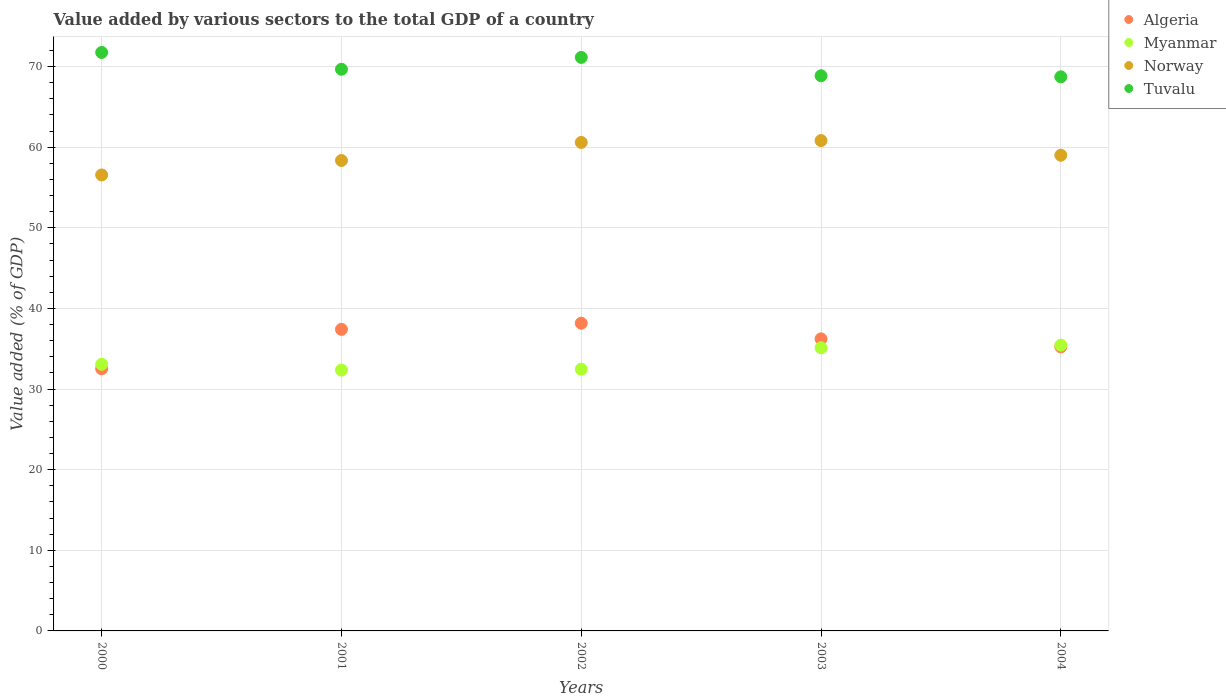How many different coloured dotlines are there?
Offer a very short reply. 4. Is the number of dotlines equal to the number of legend labels?
Your answer should be compact. Yes. What is the value added by various sectors to the total GDP in Norway in 2003?
Your answer should be very brief. 60.82. Across all years, what is the maximum value added by various sectors to the total GDP in Algeria?
Ensure brevity in your answer.  38.17. Across all years, what is the minimum value added by various sectors to the total GDP in Norway?
Your answer should be very brief. 56.56. In which year was the value added by various sectors to the total GDP in Myanmar maximum?
Your answer should be compact. 2004. In which year was the value added by various sectors to the total GDP in Algeria minimum?
Provide a succinct answer. 2000. What is the total value added by various sectors to the total GDP in Algeria in the graph?
Provide a short and direct response. 179.54. What is the difference between the value added by various sectors to the total GDP in Myanmar in 2000 and that in 2002?
Make the answer very short. 0.6. What is the difference between the value added by various sectors to the total GDP in Algeria in 2004 and the value added by various sectors to the total GDP in Norway in 2000?
Keep it short and to the point. -21.32. What is the average value added by various sectors to the total GDP in Myanmar per year?
Your answer should be very brief. 33.69. In the year 2002, what is the difference between the value added by various sectors to the total GDP in Norway and value added by various sectors to the total GDP in Myanmar?
Ensure brevity in your answer.  28.12. What is the ratio of the value added by various sectors to the total GDP in Tuvalu in 2000 to that in 2002?
Offer a terse response. 1.01. Is the value added by various sectors to the total GDP in Myanmar in 2003 less than that in 2004?
Ensure brevity in your answer.  Yes. What is the difference between the highest and the second highest value added by various sectors to the total GDP in Algeria?
Keep it short and to the point. 0.76. What is the difference between the highest and the lowest value added by various sectors to the total GDP in Tuvalu?
Provide a succinct answer. 3.02. Is it the case that in every year, the sum of the value added by various sectors to the total GDP in Norway and value added by various sectors to the total GDP in Algeria  is greater than the sum of value added by various sectors to the total GDP in Myanmar and value added by various sectors to the total GDP in Tuvalu?
Provide a short and direct response. Yes. Is it the case that in every year, the sum of the value added by various sectors to the total GDP in Tuvalu and value added by various sectors to the total GDP in Myanmar  is greater than the value added by various sectors to the total GDP in Algeria?
Provide a succinct answer. Yes. Is the value added by various sectors to the total GDP in Tuvalu strictly greater than the value added by various sectors to the total GDP in Norway over the years?
Your response must be concise. Yes. Is the value added by various sectors to the total GDP in Norway strictly less than the value added by various sectors to the total GDP in Myanmar over the years?
Your answer should be very brief. No. How many years are there in the graph?
Your response must be concise. 5. Are the values on the major ticks of Y-axis written in scientific E-notation?
Provide a succinct answer. No. Does the graph contain any zero values?
Offer a very short reply. No. Does the graph contain grids?
Offer a very short reply. Yes. Where does the legend appear in the graph?
Offer a very short reply. Top right. How are the legend labels stacked?
Give a very brief answer. Vertical. What is the title of the graph?
Keep it short and to the point. Value added by various sectors to the total GDP of a country. What is the label or title of the Y-axis?
Keep it short and to the point. Value added (% of GDP). What is the Value added (% of GDP) in Algeria in 2000?
Offer a very short reply. 32.51. What is the Value added (% of GDP) in Myanmar in 2000?
Provide a short and direct response. 33.07. What is the Value added (% of GDP) of Norway in 2000?
Make the answer very short. 56.56. What is the Value added (% of GDP) in Tuvalu in 2000?
Offer a terse response. 71.75. What is the Value added (% of GDP) of Algeria in 2001?
Provide a succinct answer. 37.4. What is the Value added (% of GDP) in Myanmar in 2001?
Give a very brief answer. 32.35. What is the Value added (% of GDP) of Norway in 2001?
Provide a short and direct response. 58.35. What is the Value added (% of GDP) in Tuvalu in 2001?
Your response must be concise. 69.66. What is the Value added (% of GDP) in Algeria in 2002?
Give a very brief answer. 38.17. What is the Value added (% of GDP) of Myanmar in 2002?
Give a very brief answer. 32.46. What is the Value added (% of GDP) in Norway in 2002?
Your response must be concise. 60.59. What is the Value added (% of GDP) of Tuvalu in 2002?
Give a very brief answer. 71.13. What is the Value added (% of GDP) in Algeria in 2003?
Ensure brevity in your answer.  36.23. What is the Value added (% of GDP) in Myanmar in 2003?
Provide a short and direct response. 35.12. What is the Value added (% of GDP) in Norway in 2003?
Keep it short and to the point. 60.82. What is the Value added (% of GDP) of Tuvalu in 2003?
Make the answer very short. 68.86. What is the Value added (% of GDP) of Algeria in 2004?
Offer a very short reply. 35.23. What is the Value added (% of GDP) of Myanmar in 2004?
Offer a terse response. 35.44. What is the Value added (% of GDP) of Norway in 2004?
Offer a terse response. 59. What is the Value added (% of GDP) in Tuvalu in 2004?
Your answer should be compact. 68.72. Across all years, what is the maximum Value added (% of GDP) of Algeria?
Offer a terse response. 38.17. Across all years, what is the maximum Value added (% of GDP) of Myanmar?
Make the answer very short. 35.44. Across all years, what is the maximum Value added (% of GDP) of Norway?
Your answer should be very brief. 60.82. Across all years, what is the maximum Value added (% of GDP) in Tuvalu?
Offer a very short reply. 71.75. Across all years, what is the minimum Value added (% of GDP) in Algeria?
Your answer should be compact. 32.51. Across all years, what is the minimum Value added (% of GDP) of Myanmar?
Keep it short and to the point. 32.35. Across all years, what is the minimum Value added (% of GDP) in Norway?
Offer a very short reply. 56.56. Across all years, what is the minimum Value added (% of GDP) of Tuvalu?
Provide a succinct answer. 68.72. What is the total Value added (% of GDP) in Algeria in the graph?
Offer a terse response. 179.54. What is the total Value added (% of GDP) of Myanmar in the graph?
Offer a very short reply. 168.45. What is the total Value added (% of GDP) of Norway in the graph?
Offer a very short reply. 295.31. What is the total Value added (% of GDP) in Tuvalu in the graph?
Your answer should be compact. 350.13. What is the difference between the Value added (% of GDP) in Algeria in 2000 and that in 2001?
Give a very brief answer. -4.89. What is the difference between the Value added (% of GDP) in Myanmar in 2000 and that in 2001?
Offer a very short reply. 0.72. What is the difference between the Value added (% of GDP) in Norway in 2000 and that in 2001?
Provide a short and direct response. -1.79. What is the difference between the Value added (% of GDP) in Tuvalu in 2000 and that in 2001?
Your answer should be compact. 2.08. What is the difference between the Value added (% of GDP) in Algeria in 2000 and that in 2002?
Offer a very short reply. -5.65. What is the difference between the Value added (% of GDP) in Myanmar in 2000 and that in 2002?
Provide a succinct answer. 0.6. What is the difference between the Value added (% of GDP) in Norway in 2000 and that in 2002?
Your response must be concise. -4.03. What is the difference between the Value added (% of GDP) in Tuvalu in 2000 and that in 2002?
Provide a succinct answer. 0.61. What is the difference between the Value added (% of GDP) in Algeria in 2000 and that in 2003?
Your answer should be very brief. -3.71. What is the difference between the Value added (% of GDP) of Myanmar in 2000 and that in 2003?
Your answer should be compact. -2.05. What is the difference between the Value added (% of GDP) of Norway in 2000 and that in 2003?
Your answer should be compact. -4.26. What is the difference between the Value added (% of GDP) of Tuvalu in 2000 and that in 2003?
Give a very brief answer. 2.89. What is the difference between the Value added (% of GDP) in Algeria in 2000 and that in 2004?
Offer a very short reply. -2.72. What is the difference between the Value added (% of GDP) of Myanmar in 2000 and that in 2004?
Offer a very short reply. -2.37. What is the difference between the Value added (% of GDP) in Norway in 2000 and that in 2004?
Ensure brevity in your answer.  -2.45. What is the difference between the Value added (% of GDP) in Tuvalu in 2000 and that in 2004?
Your answer should be compact. 3.02. What is the difference between the Value added (% of GDP) in Algeria in 2001 and that in 2002?
Offer a very short reply. -0.76. What is the difference between the Value added (% of GDP) of Myanmar in 2001 and that in 2002?
Ensure brevity in your answer.  -0.11. What is the difference between the Value added (% of GDP) in Norway in 2001 and that in 2002?
Keep it short and to the point. -2.24. What is the difference between the Value added (% of GDP) of Tuvalu in 2001 and that in 2002?
Provide a short and direct response. -1.47. What is the difference between the Value added (% of GDP) of Algeria in 2001 and that in 2003?
Give a very brief answer. 1.18. What is the difference between the Value added (% of GDP) in Myanmar in 2001 and that in 2003?
Give a very brief answer. -2.77. What is the difference between the Value added (% of GDP) of Norway in 2001 and that in 2003?
Give a very brief answer. -2.47. What is the difference between the Value added (% of GDP) of Tuvalu in 2001 and that in 2003?
Your response must be concise. 0.8. What is the difference between the Value added (% of GDP) in Algeria in 2001 and that in 2004?
Offer a very short reply. 2.17. What is the difference between the Value added (% of GDP) of Myanmar in 2001 and that in 2004?
Provide a succinct answer. -3.09. What is the difference between the Value added (% of GDP) of Norway in 2001 and that in 2004?
Your response must be concise. -0.65. What is the difference between the Value added (% of GDP) in Tuvalu in 2001 and that in 2004?
Provide a succinct answer. 0.94. What is the difference between the Value added (% of GDP) in Algeria in 2002 and that in 2003?
Provide a short and direct response. 1.94. What is the difference between the Value added (% of GDP) of Myanmar in 2002 and that in 2003?
Give a very brief answer. -2.66. What is the difference between the Value added (% of GDP) of Norway in 2002 and that in 2003?
Make the answer very short. -0.23. What is the difference between the Value added (% of GDP) of Tuvalu in 2002 and that in 2003?
Provide a short and direct response. 2.27. What is the difference between the Value added (% of GDP) in Algeria in 2002 and that in 2004?
Provide a short and direct response. 2.93. What is the difference between the Value added (% of GDP) of Myanmar in 2002 and that in 2004?
Make the answer very short. -2.98. What is the difference between the Value added (% of GDP) of Norway in 2002 and that in 2004?
Provide a short and direct response. 1.58. What is the difference between the Value added (% of GDP) in Tuvalu in 2002 and that in 2004?
Offer a very short reply. 2.41. What is the difference between the Value added (% of GDP) of Algeria in 2003 and that in 2004?
Offer a very short reply. 0.99. What is the difference between the Value added (% of GDP) of Myanmar in 2003 and that in 2004?
Ensure brevity in your answer.  -0.32. What is the difference between the Value added (% of GDP) in Norway in 2003 and that in 2004?
Provide a short and direct response. 1.82. What is the difference between the Value added (% of GDP) of Tuvalu in 2003 and that in 2004?
Provide a succinct answer. 0.14. What is the difference between the Value added (% of GDP) of Algeria in 2000 and the Value added (% of GDP) of Myanmar in 2001?
Offer a terse response. 0.16. What is the difference between the Value added (% of GDP) of Algeria in 2000 and the Value added (% of GDP) of Norway in 2001?
Your answer should be compact. -25.84. What is the difference between the Value added (% of GDP) of Algeria in 2000 and the Value added (% of GDP) of Tuvalu in 2001?
Give a very brief answer. -37.15. What is the difference between the Value added (% of GDP) in Myanmar in 2000 and the Value added (% of GDP) in Norway in 2001?
Provide a succinct answer. -25.28. What is the difference between the Value added (% of GDP) of Myanmar in 2000 and the Value added (% of GDP) of Tuvalu in 2001?
Give a very brief answer. -36.59. What is the difference between the Value added (% of GDP) of Norway in 2000 and the Value added (% of GDP) of Tuvalu in 2001?
Ensure brevity in your answer.  -13.11. What is the difference between the Value added (% of GDP) of Algeria in 2000 and the Value added (% of GDP) of Myanmar in 2002?
Provide a short and direct response. 0.05. What is the difference between the Value added (% of GDP) in Algeria in 2000 and the Value added (% of GDP) in Norway in 2002?
Your answer should be very brief. -28.07. What is the difference between the Value added (% of GDP) in Algeria in 2000 and the Value added (% of GDP) in Tuvalu in 2002?
Ensure brevity in your answer.  -38.62. What is the difference between the Value added (% of GDP) of Myanmar in 2000 and the Value added (% of GDP) of Norway in 2002?
Your answer should be compact. -27.52. What is the difference between the Value added (% of GDP) in Myanmar in 2000 and the Value added (% of GDP) in Tuvalu in 2002?
Your answer should be very brief. -38.06. What is the difference between the Value added (% of GDP) of Norway in 2000 and the Value added (% of GDP) of Tuvalu in 2002?
Provide a succinct answer. -14.58. What is the difference between the Value added (% of GDP) in Algeria in 2000 and the Value added (% of GDP) in Myanmar in 2003?
Offer a terse response. -2.61. What is the difference between the Value added (% of GDP) of Algeria in 2000 and the Value added (% of GDP) of Norway in 2003?
Keep it short and to the point. -28.3. What is the difference between the Value added (% of GDP) in Algeria in 2000 and the Value added (% of GDP) in Tuvalu in 2003?
Ensure brevity in your answer.  -36.35. What is the difference between the Value added (% of GDP) in Myanmar in 2000 and the Value added (% of GDP) in Norway in 2003?
Offer a terse response. -27.75. What is the difference between the Value added (% of GDP) of Myanmar in 2000 and the Value added (% of GDP) of Tuvalu in 2003?
Provide a short and direct response. -35.79. What is the difference between the Value added (% of GDP) in Norway in 2000 and the Value added (% of GDP) in Tuvalu in 2003?
Make the answer very short. -12.3. What is the difference between the Value added (% of GDP) in Algeria in 2000 and the Value added (% of GDP) in Myanmar in 2004?
Provide a succinct answer. -2.93. What is the difference between the Value added (% of GDP) of Algeria in 2000 and the Value added (% of GDP) of Norway in 2004?
Offer a terse response. -26.49. What is the difference between the Value added (% of GDP) in Algeria in 2000 and the Value added (% of GDP) in Tuvalu in 2004?
Your answer should be compact. -36.21. What is the difference between the Value added (% of GDP) of Myanmar in 2000 and the Value added (% of GDP) of Norway in 2004?
Give a very brief answer. -25.93. What is the difference between the Value added (% of GDP) in Myanmar in 2000 and the Value added (% of GDP) in Tuvalu in 2004?
Offer a very short reply. -35.65. What is the difference between the Value added (% of GDP) in Norway in 2000 and the Value added (% of GDP) in Tuvalu in 2004?
Give a very brief answer. -12.17. What is the difference between the Value added (% of GDP) in Algeria in 2001 and the Value added (% of GDP) in Myanmar in 2002?
Your answer should be very brief. 4.94. What is the difference between the Value added (% of GDP) in Algeria in 2001 and the Value added (% of GDP) in Norway in 2002?
Offer a terse response. -23.18. What is the difference between the Value added (% of GDP) in Algeria in 2001 and the Value added (% of GDP) in Tuvalu in 2002?
Offer a very short reply. -33.73. What is the difference between the Value added (% of GDP) of Myanmar in 2001 and the Value added (% of GDP) of Norway in 2002?
Offer a terse response. -28.24. What is the difference between the Value added (% of GDP) of Myanmar in 2001 and the Value added (% of GDP) of Tuvalu in 2002?
Provide a succinct answer. -38.78. What is the difference between the Value added (% of GDP) in Norway in 2001 and the Value added (% of GDP) in Tuvalu in 2002?
Your answer should be very brief. -12.78. What is the difference between the Value added (% of GDP) of Algeria in 2001 and the Value added (% of GDP) of Myanmar in 2003?
Provide a succinct answer. 2.28. What is the difference between the Value added (% of GDP) in Algeria in 2001 and the Value added (% of GDP) in Norway in 2003?
Make the answer very short. -23.41. What is the difference between the Value added (% of GDP) of Algeria in 2001 and the Value added (% of GDP) of Tuvalu in 2003?
Ensure brevity in your answer.  -31.46. What is the difference between the Value added (% of GDP) of Myanmar in 2001 and the Value added (% of GDP) of Norway in 2003?
Your answer should be very brief. -28.47. What is the difference between the Value added (% of GDP) in Myanmar in 2001 and the Value added (% of GDP) in Tuvalu in 2003?
Keep it short and to the point. -36.51. What is the difference between the Value added (% of GDP) in Norway in 2001 and the Value added (% of GDP) in Tuvalu in 2003?
Offer a terse response. -10.51. What is the difference between the Value added (% of GDP) in Algeria in 2001 and the Value added (% of GDP) in Myanmar in 2004?
Keep it short and to the point. 1.96. What is the difference between the Value added (% of GDP) of Algeria in 2001 and the Value added (% of GDP) of Norway in 2004?
Ensure brevity in your answer.  -21.6. What is the difference between the Value added (% of GDP) in Algeria in 2001 and the Value added (% of GDP) in Tuvalu in 2004?
Make the answer very short. -31.32. What is the difference between the Value added (% of GDP) of Myanmar in 2001 and the Value added (% of GDP) of Norway in 2004?
Keep it short and to the point. -26.65. What is the difference between the Value added (% of GDP) in Myanmar in 2001 and the Value added (% of GDP) in Tuvalu in 2004?
Your answer should be very brief. -36.37. What is the difference between the Value added (% of GDP) of Norway in 2001 and the Value added (% of GDP) of Tuvalu in 2004?
Provide a short and direct response. -10.38. What is the difference between the Value added (% of GDP) of Algeria in 2002 and the Value added (% of GDP) of Myanmar in 2003?
Provide a short and direct response. 3.04. What is the difference between the Value added (% of GDP) in Algeria in 2002 and the Value added (% of GDP) in Norway in 2003?
Make the answer very short. -22.65. What is the difference between the Value added (% of GDP) of Algeria in 2002 and the Value added (% of GDP) of Tuvalu in 2003?
Offer a terse response. -30.69. What is the difference between the Value added (% of GDP) of Myanmar in 2002 and the Value added (% of GDP) of Norway in 2003?
Your answer should be compact. -28.35. What is the difference between the Value added (% of GDP) in Myanmar in 2002 and the Value added (% of GDP) in Tuvalu in 2003?
Keep it short and to the point. -36.4. What is the difference between the Value added (% of GDP) of Norway in 2002 and the Value added (% of GDP) of Tuvalu in 2003?
Your answer should be very brief. -8.27. What is the difference between the Value added (% of GDP) of Algeria in 2002 and the Value added (% of GDP) of Myanmar in 2004?
Keep it short and to the point. 2.72. What is the difference between the Value added (% of GDP) in Algeria in 2002 and the Value added (% of GDP) in Norway in 2004?
Give a very brief answer. -20.84. What is the difference between the Value added (% of GDP) in Algeria in 2002 and the Value added (% of GDP) in Tuvalu in 2004?
Your response must be concise. -30.56. What is the difference between the Value added (% of GDP) in Myanmar in 2002 and the Value added (% of GDP) in Norway in 2004?
Your response must be concise. -26.54. What is the difference between the Value added (% of GDP) in Myanmar in 2002 and the Value added (% of GDP) in Tuvalu in 2004?
Your answer should be compact. -36.26. What is the difference between the Value added (% of GDP) in Norway in 2002 and the Value added (% of GDP) in Tuvalu in 2004?
Offer a very short reply. -8.14. What is the difference between the Value added (% of GDP) of Algeria in 2003 and the Value added (% of GDP) of Myanmar in 2004?
Ensure brevity in your answer.  0.78. What is the difference between the Value added (% of GDP) of Algeria in 2003 and the Value added (% of GDP) of Norway in 2004?
Your response must be concise. -22.78. What is the difference between the Value added (% of GDP) of Algeria in 2003 and the Value added (% of GDP) of Tuvalu in 2004?
Make the answer very short. -32.5. What is the difference between the Value added (% of GDP) in Myanmar in 2003 and the Value added (% of GDP) in Norway in 2004?
Your answer should be very brief. -23.88. What is the difference between the Value added (% of GDP) of Myanmar in 2003 and the Value added (% of GDP) of Tuvalu in 2004?
Provide a short and direct response. -33.6. What is the difference between the Value added (% of GDP) of Norway in 2003 and the Value added (% of GDP) of Tuvalu in 2004?
Your answer should be compact. -7.91. What is the average Value added (% of GDP) in Algeria per year?
Make the answer very short. 35.91. What is the average Value added (% of GDP) in Myanmar per year?
Provide a short and direct response. 33.69. What is the average Value added (% of GDP) of Norway per year?
Offer a terse response. 59.06. What is the average Value added (% of GDP) of Tuvalu per year?
Provide a succinct answer. 70.03. In the year 2000, what is the difference between the Value added (% of GDP) of Algeria and Value added (% of GDP) of Myanmar?
Provide a short and direct response. -0.56. In the year 2000, what is the difference between the Value added (% of GDP) of Algeria and Value added (% of GDP) of Norway?
Make the answer very short. -24.04. In the year 2000, what is the difference between the Value added (% of GDP) in Algeria and Value added (% of GDP) in Tuvalu?
Keep it short and to the point. -39.23. In the year 2000, what is the difference between the Value added (% of GDP) in Myanmar and Value added (% of GDP) in Norway?
Keep it short and to the point. -23.49. In the year 2000, what is the difference between the Value added (% of GDP) of Myanmar and Value added (% of GDP) of Tuvalu?
Make the answer very short. -38.68. In the year 2000, what is the difference between the Value added (% of GDP) in Norway and Value added (% of GDP) in Tuvalu?
Keep it short and to the point. -15.19. In the year 2001, what is the difference between the Value added (% of GDP) in Algeria and Value added (% of GDP) in Myanmar?
Make the answer very short. 5.05. In the year 2001, what is the difference between the Value added (% of GDP) of Algeria and Value added (% of GDP) of Norway?
Give a very brief answer. -20.94. In the year 2001, what is the difference between the Value added (% of GDP) of Algeria and Value added (% of GDP) of Tuvalu?
Your answer should be compact. -32.26. In the year 2001, what is the difference between the Value added (% of GDP) in Myanmar and Value added (% of GDP) in Norway?
Ensure brevity in your answer.  -26. In the year 2001, what is the difference between the Value added (% of GDP) of Myanmar and Value added (% of GDP) of Tuvalu?
Your response must be concise. -37.31. In the year 2001, what is the difference between the Value added (% of GDP) in Norway and Value added (% of GDP) in Tuvalu?
Give a very brief answer. -11.32. In the year 2002, what is the difference between the Value added (% of GDP) in Algeria and Value added (% of GDP) in Myanmar?
Ensure brevity in your answer.  5.7. In the year 2002, what is the difference between the Value added (% of GDP) in Algeria and Value added (% of GDP) in Norway?
Offer a very short reply. -22.42. In the year 2002, what is the difference between the Value added (% of GDP) in Algeria and Value added (% of GDP) in Tuvalu?
Provide a short and direct response. -32.97. In the year 2002, what is the difference between the Value added (% of GDP) of Myanmar and Value added (% of GDP) of Norway?
Provide a short and direct response. -28.12. In the year 2002, what is the difference between the Value added (% of GDP) in Myanmar and Value added (% of GDP) in Tuvalu?
Keep it short and to the point. -38.67. In the year 2002, what is the difference between the Value added (% of GDP) in Norway and Value added (% of GDP) in Tuvalu?
Make the answer very short. -10.55. In the year 2003, what is the difference between the Value added (% of GDP) of Algeria and Value added (% of GDP) of Myanmar?
Make the answer very short. 1.1. In the year 2003, what is the difference between the Value added (% of GDP) of Algeria and Value added (% of GDP) of Norway?
Your response must be concise. -24.59. In the year 2003, what is the difference between the Value added (% of GDP) of Algeria and Value added (% of GDP) of Tuvalu?
Your response must be concise. -32.63. In the year 2003, what is the difference between the Value added (% of GDP) of Myanmar and Value added (% of GDP) of Norway?
Give a very brief answer. -25.7. In the year 2003, what is the difference between the Value added (% of GDP) in Myanmar and Value added (% of GDP) in Tuvalu?
Make the answer very short. -33.74. In the year 2003, what is the difference between the Value added (% of GDP) of Norway and Value added (% of GDP) of Tuvalu?
Your answer should be very brief. -8.04. In the year 2004, what is the difference between the Value added (% of GDP) in Algeria and Value added (% of GDP) in Myanmar?
Offer a very short reply. -0.21. In the year 2004, what is the difference between the Value added (% of GDP) in Algeria and Value added (% of GDP) in Norway?
Offer a very short reply. -23.77. In the year 2004, what is the difference between the Value added (% of GDP) in Algeria and Value added (% of GDP) in Tuvalu?
Keep it short and to the point. -33.49. In the year 2004, what is the difference between the Value added (% of GDP) of Myanmar and Value added (% of GDP) of Norway?
Your answer should be very brief. -23.56. In the year 2004, what is the difference between the Value added (% of GDP) in Myanmar and Value added (% of GDP) in Tuvalu?
Your answer should be compact. -33.28. In the year 2004, what is the difference between the Value added (% of GDP) in Norway and Value added (% of GDP) in Tuvalu?
Keep it short and to the point. -9.72. What is the ratio of the Value added (% of GDP) of Algeria in 2000 to that in 2001?
Your answer should be very brief. 0.87. What is the ratio of the Value added (% of GDP) of Myanmar in 2000 to that in 2001?
Offer a terse response. 1.02. What is the ratio of the Value added (% of GDP) of Norway in 2000 to that in 2001?
Ensure brevity in your answer.  0.97. What is the ratio of the Value added (% of GDP) of Tuvalu in 2000 to that in 2001?
Your response must be concise. 1.03. What is the ratio of the Value added (% of GDP) in Algeria in 2000 to that in 2002?
Your answer should be very brief. 0.85. What is the ratio of the Value added (% of GDP) in Myanmar in 2000 to that in 2002?
Your answer should be compact. 1.02. What is the ratio of the Value added (% of GDP) of Norway in 2000 to that in 2002?
Your answer should be compact. 0.93. What is the ratio of the Value added (% of GDP) of Tuvalu in 2000 to that in 2002?
Make the answer very short. 1.01. What is the ratio of the Value added (% of GDP) of Algeria in 2000 to that in 2003?
Provide a succinct answer. 0.9. What is the ratio of the Value added (% of GDP) in Myanmar in 2000 to that in 2003?
Keep it short and to the point. 0.94. What is the ratio of the Value added (% of GDP) of Norway in 2000 to that in 2003?
Your response must be concise. 0.93. What is the ratio of the Value added (% of GDP) in Tuvalu in 2000 to that in 2003?
Make the answer very short. 1.04. What is the ratio of the Value added (% of GDP) of Algeria in 2000 to that in 2004?
Provide a short and direct response. 0.92. What is the ratio of the Value added (% of GDP) in Myanmar in 2000 to that in 2004?
Ensure brevity in your answer.  0.93. What is the ratio of the Value added (% of GDP) in Norway in 2000 to that in 2004?
Your answer should be compact. 0.96. What is the ratio of the Value added (% of GDP) of Tuvalu in 2000 to that in 2004?
Make the answer very short. 1.04. What is the ratio of the Value added (% of GDP) of Algeria in 2001 to that in 2002?
Make the answer very short. 0.98. What is the ratio of the Value added (% of GDP) of Norway in 2001 to that in 2002?
Ensure brevity in your answer.  0.96. What is the ratio of the Value added (% of GDP) in Tuvalu in 2001 to that in 2002?
Provide a short and direct response. 0.98. What is the ratio of the Value added (% of GDP) of Algeria in 2001 to that in 2003?
Provide a succinct answer. 1.03. What is the ratio of the Value added (% of GDP) in Myanmar in 2001 to that in 2003?
Keep it short and to the point. 0.92. What is the ratio of the Value added (% of GDP) of Norway in 2001 to that in 2003?
Provide a succinct answer. 0.96. What is the ratio of the Value added (% of GDP) in Tuvalu in 2001 to that in 2003?
Make the answer very short. 1.01. What is the ratio of the Value added (% of GDP) of Algeria in 2001 to that in 2004?
Your response must be concise. 1.06. What is the ratio of the Value added (% of GDP) in Myanmar in 2001 to that in 2004?
Your answer should be compact. 0.91. What is the ratio of the Value added (% of GDP) of Norway in 2001 to that in 2004?
Make the answer very short. 0.99. What is the ratio of the Value added (% of GDP) of Tuvalu in 2001 to that in 2004?
Your answer should be very brief. 1.01. What is the ratio of the Value added (% of GDP) in Algeria in 2002 to that in 2003?
Offer a very short reply. 1.05. What is the ratio of the Value added (% of GDP) in Myanmar in 2002 to that in 2003?
Keep it short and to the point. 0.92. What is the ratio of the Value added (% of GDP) of Norway in 2002 to that in 2003?
Give a very brief answer. 1. What is the ratio of the Value added (% of GDP) of Tuvalu in 2002 to that in 2003?
Make the answer very short. 1.03. What is the ratio of the Value added (% of GDP) in Algeria in 2002 to that in 2004?
Give a very brief answer. 1.08. What is the ratio of the Value added (% of GDP) in Myanmar in 2002 to that in 2004?
Provide a short and direct response. 0.92. What is the ratio of the Value added (% of GDP) of Norway in 2002 to that in 2004?
Your response must be concise. 1.03. What is the ratio of the Value added (% of GDP) in Tuvalu in 2002 to that in 2004?
Ensure brevity in your answer.  1.04. What is the ratio of the Value added (% of GDP) of Algeria in 2003 to that in 2004?
Your response must be concise. 1.03. What is the ratio of the Value added (% of GDP) in Myanmar in 2003 to that in 2004?
Provide a succinct answer. 0.99. What is the ratio of the Value added (% of GDP) in Norway in 2003 to that in 2004?
Your answer should be compact. 1.03. What is the ratio of the Value added (% of GDP) in Tuvalu in 2003 to that in 2004?
Give a very brief answer. 1. What is the difference between the highest and the second highest Value added (% of GDP) in Algeria?
Provide a short and direct response. 0.76. What is the difference between the highest and the second highest Value added (% of GDP) in Myanmar?
Your response must be concise. 0.32. What is the difference between the highest and the second highest Value added (% of GDP) in Norway?
Provide a short and direct response. 0.23. What is the difference between the highest and the second highest Value added (% of GDP) in Tuvalu?
Provide a succinct answer. 0.61. What is the difference between the highest and the lowest Value added (% of GDP) in Algeria?
Your answer should be very brief. 5.65. What is the difference between the highest and the lowest Value added (% of GDP) of Myanmar?
Provide a succinct answer. 3.09. What is the difference between the highest and the lowest Value added (% of GDP) of Norway?
Keep it short and to the point. 4.26. What is the difference between the highest and the lowest Value added (% of GDP) in Tuvalu?
Offer a very short reply. 3.02. 